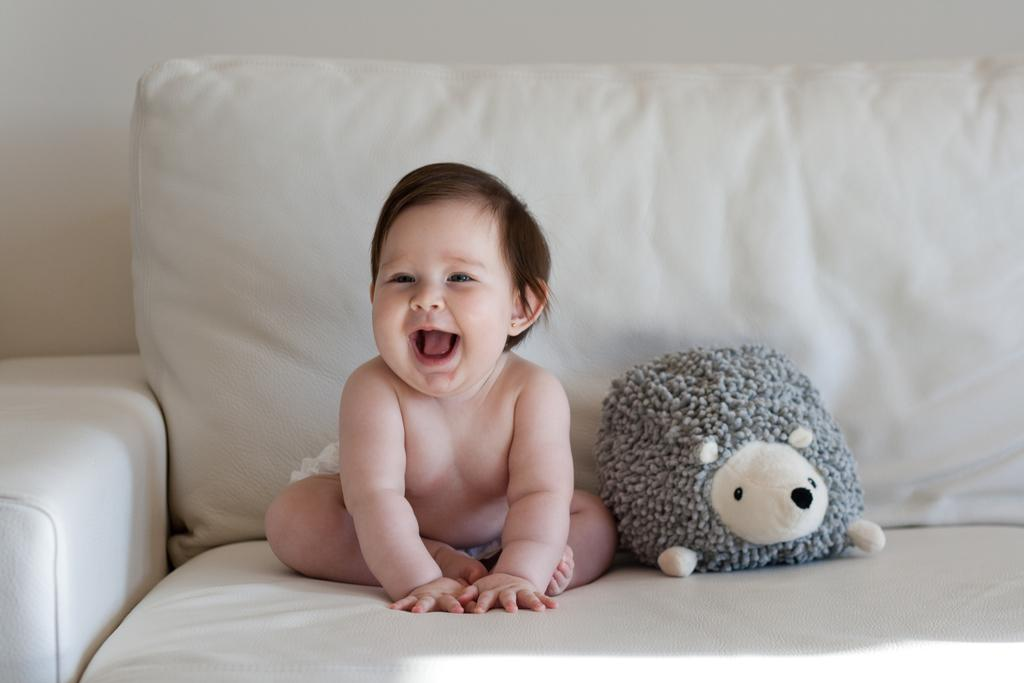What is the baby doing in the image? The baby is sitting on the couch in the image. What object is near the baby? There is a toy next to the baby. Can you describe the toy's appearance? The toy is in ash and white color. What can be seen in the background of the image? There is a white wall in the background. How many dogs are accompanying the baby on the journey in the image? There are no dogs or journeys depicted in the image; it features a baby sitting on a couch with a toy next to them. 